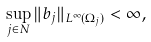<formula> <loc_0><loc_0><loc_500><loc_500>\sup _ { j \in N } \| b _ { j } \| _ { L ^ { \infty } ( \Omega _ { j } ) } < \infty ,</formula> 